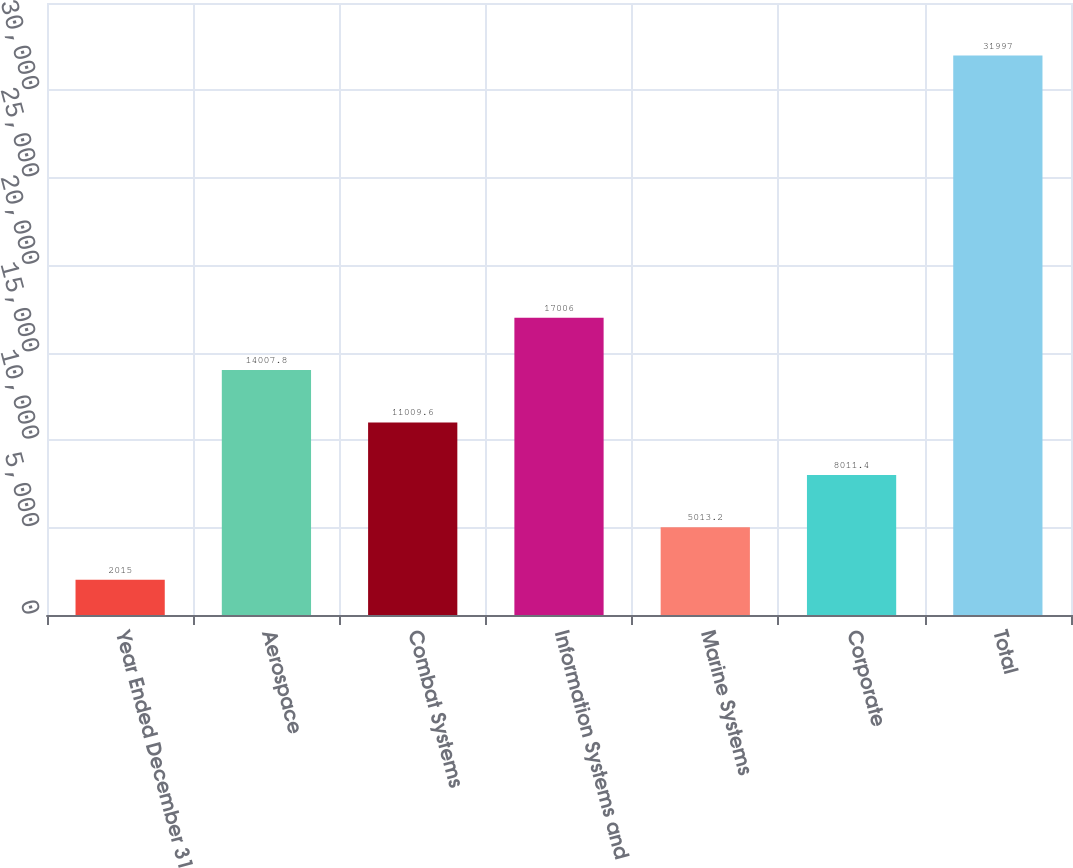Convert chart. <chart><loc_0><loc_0><loc_500><loc_500><bar_chart><fcel>Year Ended December 31<fcel>Aerospace<fcel>Combat Systems<fcel>Information Systems and<fcel>Marine Systems<fcel>Corporate<fcel>Total<nl><fcel>2015<fcel>14007.8<fcel>11009.6<fcel>17006<fcel>5013.2<fcel>8011.4<fcel>31997<nl></chart> 